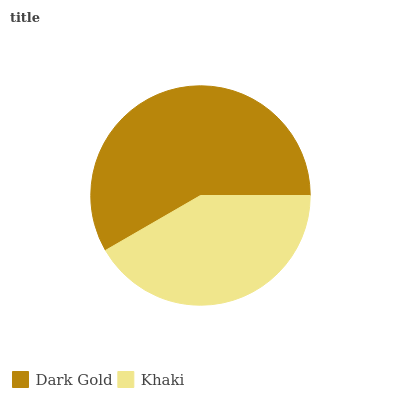Is Khaki the minimum?
Answer yes or no. Yes. Is Dark Gold the maximum?
Answer yes or no. Yes. Is Khaki the maximum?
Answer yes or no. No. Is Dark Gold greater than Khaki?
Answer yes or no. Yes. Is Khaki less than Dark Gold?
Answer yes or no. Yes. Is Khaki greater than Dark Gold?
Answer yes or no. No. Is Dark Gold less than Khaki?
Answer yes or no. No. Is Dark Gold the high median?
Answer yes or no. Yes. Is Khaki the low median?
Answer yes or no. Yes. Is Khaki the high median?
Answer yes or no. No. Is Dark Gold the low median?
Answer yes or no. No. 